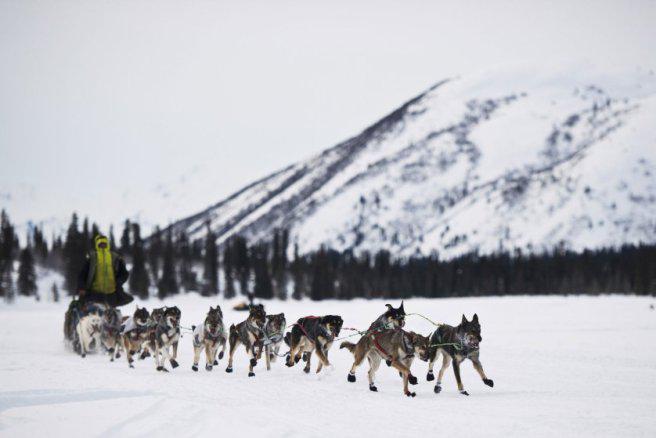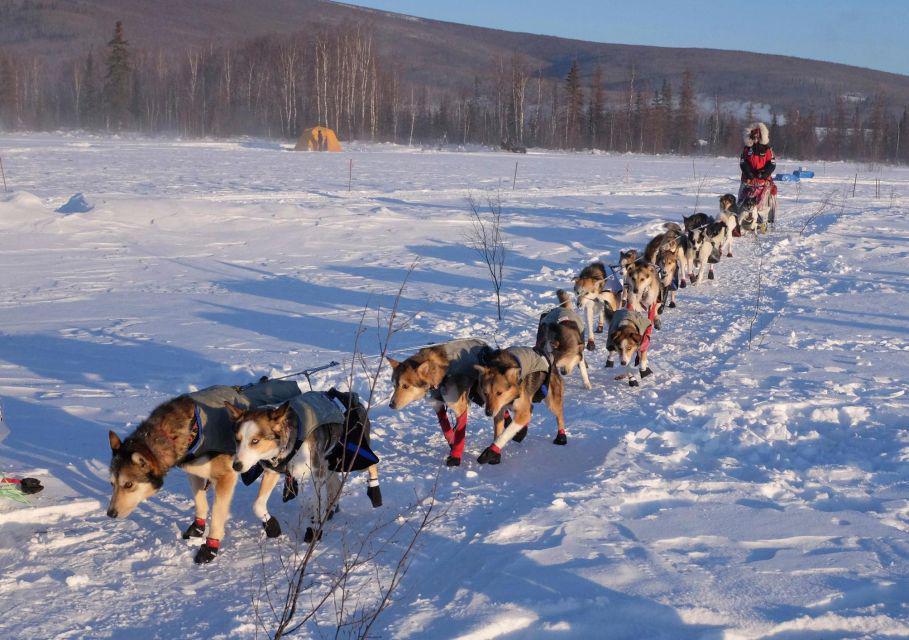The first image is the image on the left, the second image is the image on the right. Assess this claim about the two images: "The sun gives off a soft glow behind the clouds in at least one of the images.". Correct or not? Answer yes or no. No. The first image is the image on the left, the second image is the image on the right. Assess this claim about the two images: "Tall trees but no tall hills line the horizon in both images of sled dogs moving across the snow, and at least one image shows the sun shining above the trees.". Correct or not? Answer yes or no. No. 